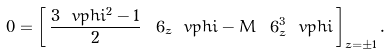<formula> <loc_0><loc_0><loc_500><loc_500>0 = \left [ \, \frac { 3 \ v p h i ^ { 2 } - 1 } { 2 } \, \ 6 _ { z } \ v p h i - M \, \ 6 _ { z } ^ { 3 } \ v p h i \, \right ] _ { z = \pm 1 } .</formula> 